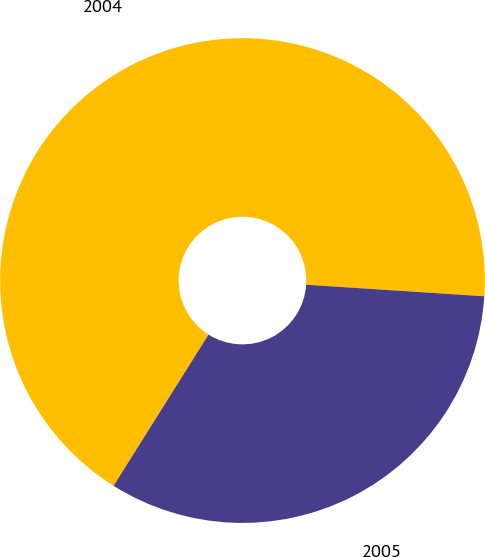Convert chart. <chart><loc_0><loc_0><loc_500><loc_500><pie_chart><fcel>2004<fcel>2005<nl><fcel>67.11%<fcel>32.89%<nl></chart> 